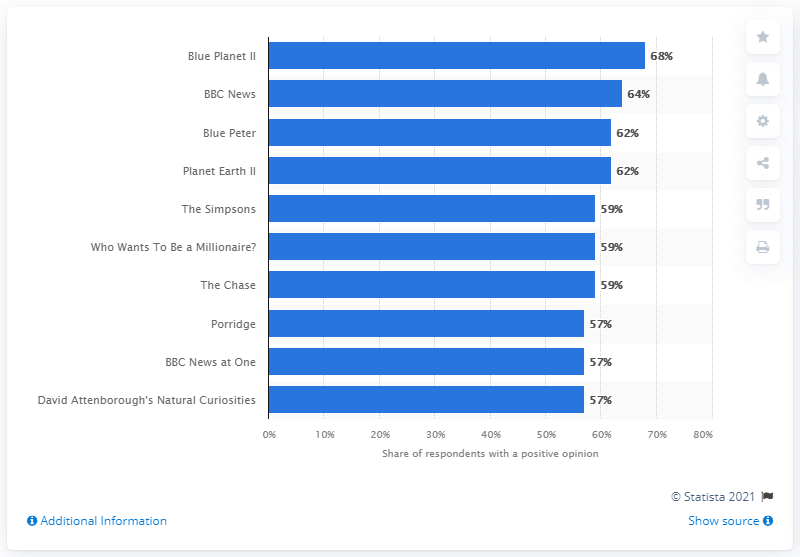What was the highest ranked show in the UK in the first quarter of 2021? According to the visual data provided, the highest ranked show in the UK in the first quarter of 2021 was not 'Blue Planet II' but another program that appears to have a higher percentage of respondents with a positive opinion. 